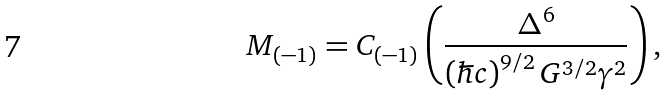Convert formula to latex. <formula><loc_0><loc_0><loc_500><loc_500>M _ { ( - 1 ) } = C _ { ( - 1 ) } \left ( \frac { \Delta ^ { 6 } } { \left ( \hbar { c } \right ) ^ { 9 / 2 } G ^ { 3 / 2 } \gamma ^ { 2 } } \right ) ,</formula> 